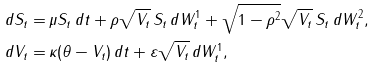<formula> <loc_0><loc_0><loc_500><loc_500>d S _ { t } = & \, \mu S _ { t } \, d t + \rho \sqrt { V _ { t } } \, S _ { t } \, d W ^ { 1 } _ { t } + \sqrt { 1 - \rho ^ { 2 } } \sqrt { V _ { t } } \, S _ { t } \, d W ^ { 2 } _ { t } , \\ d V _ { t } = & \, \kappa ( \theta - V _ { t } ) \, d t + \varepsilon \sqrt { V _ { t } } \, d W ^ { 1 } _ { t } ,</formula> 